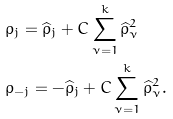Convert formula to latex. <formula><loc_0><loc_0><loc_500><loc_500>& \rho _ { j } = \widehat { \rho } _ { j } + C \sum _ { \nu = 1 } ^ { k } \widehat { \rho } _ { \nu } ^ { 2 } \\ & \rho _ { - j } = - \widehat { \rho } _ { j } + C \sum _ { \nu = 1 } ^ { k } \widehat { \rho } _ { \nu } ^ { 2 } .</formula> 